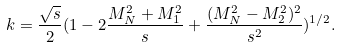Convert formula to latex. <formula><loc_0><loc_0><loc_500><loc_500>k = \frac { \sqrt { s } } { 2 } ( 1 - 2 \frac { M ^ { 2 } _ { N } + M ^ { 2 } _ { 1 } } { s } + \frac { ( M ^ { 2 } _ { N } - M ^ { 2 } _ { 2 } ) ^ { 2 } } { s ^ { 2 } } ) ^ { 1 / 2 } .</formula> 